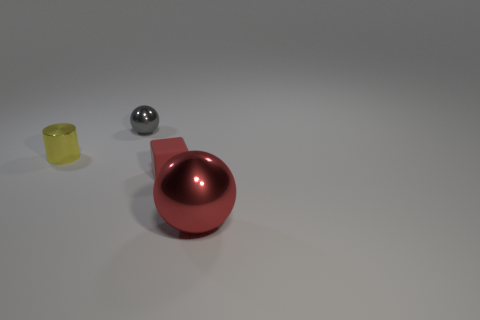Is there any indication of the time of day in this image? The image appears to be taken in an indoor setting with controlled lighting, making it difficult to determine the time of day based on the available visual information. 